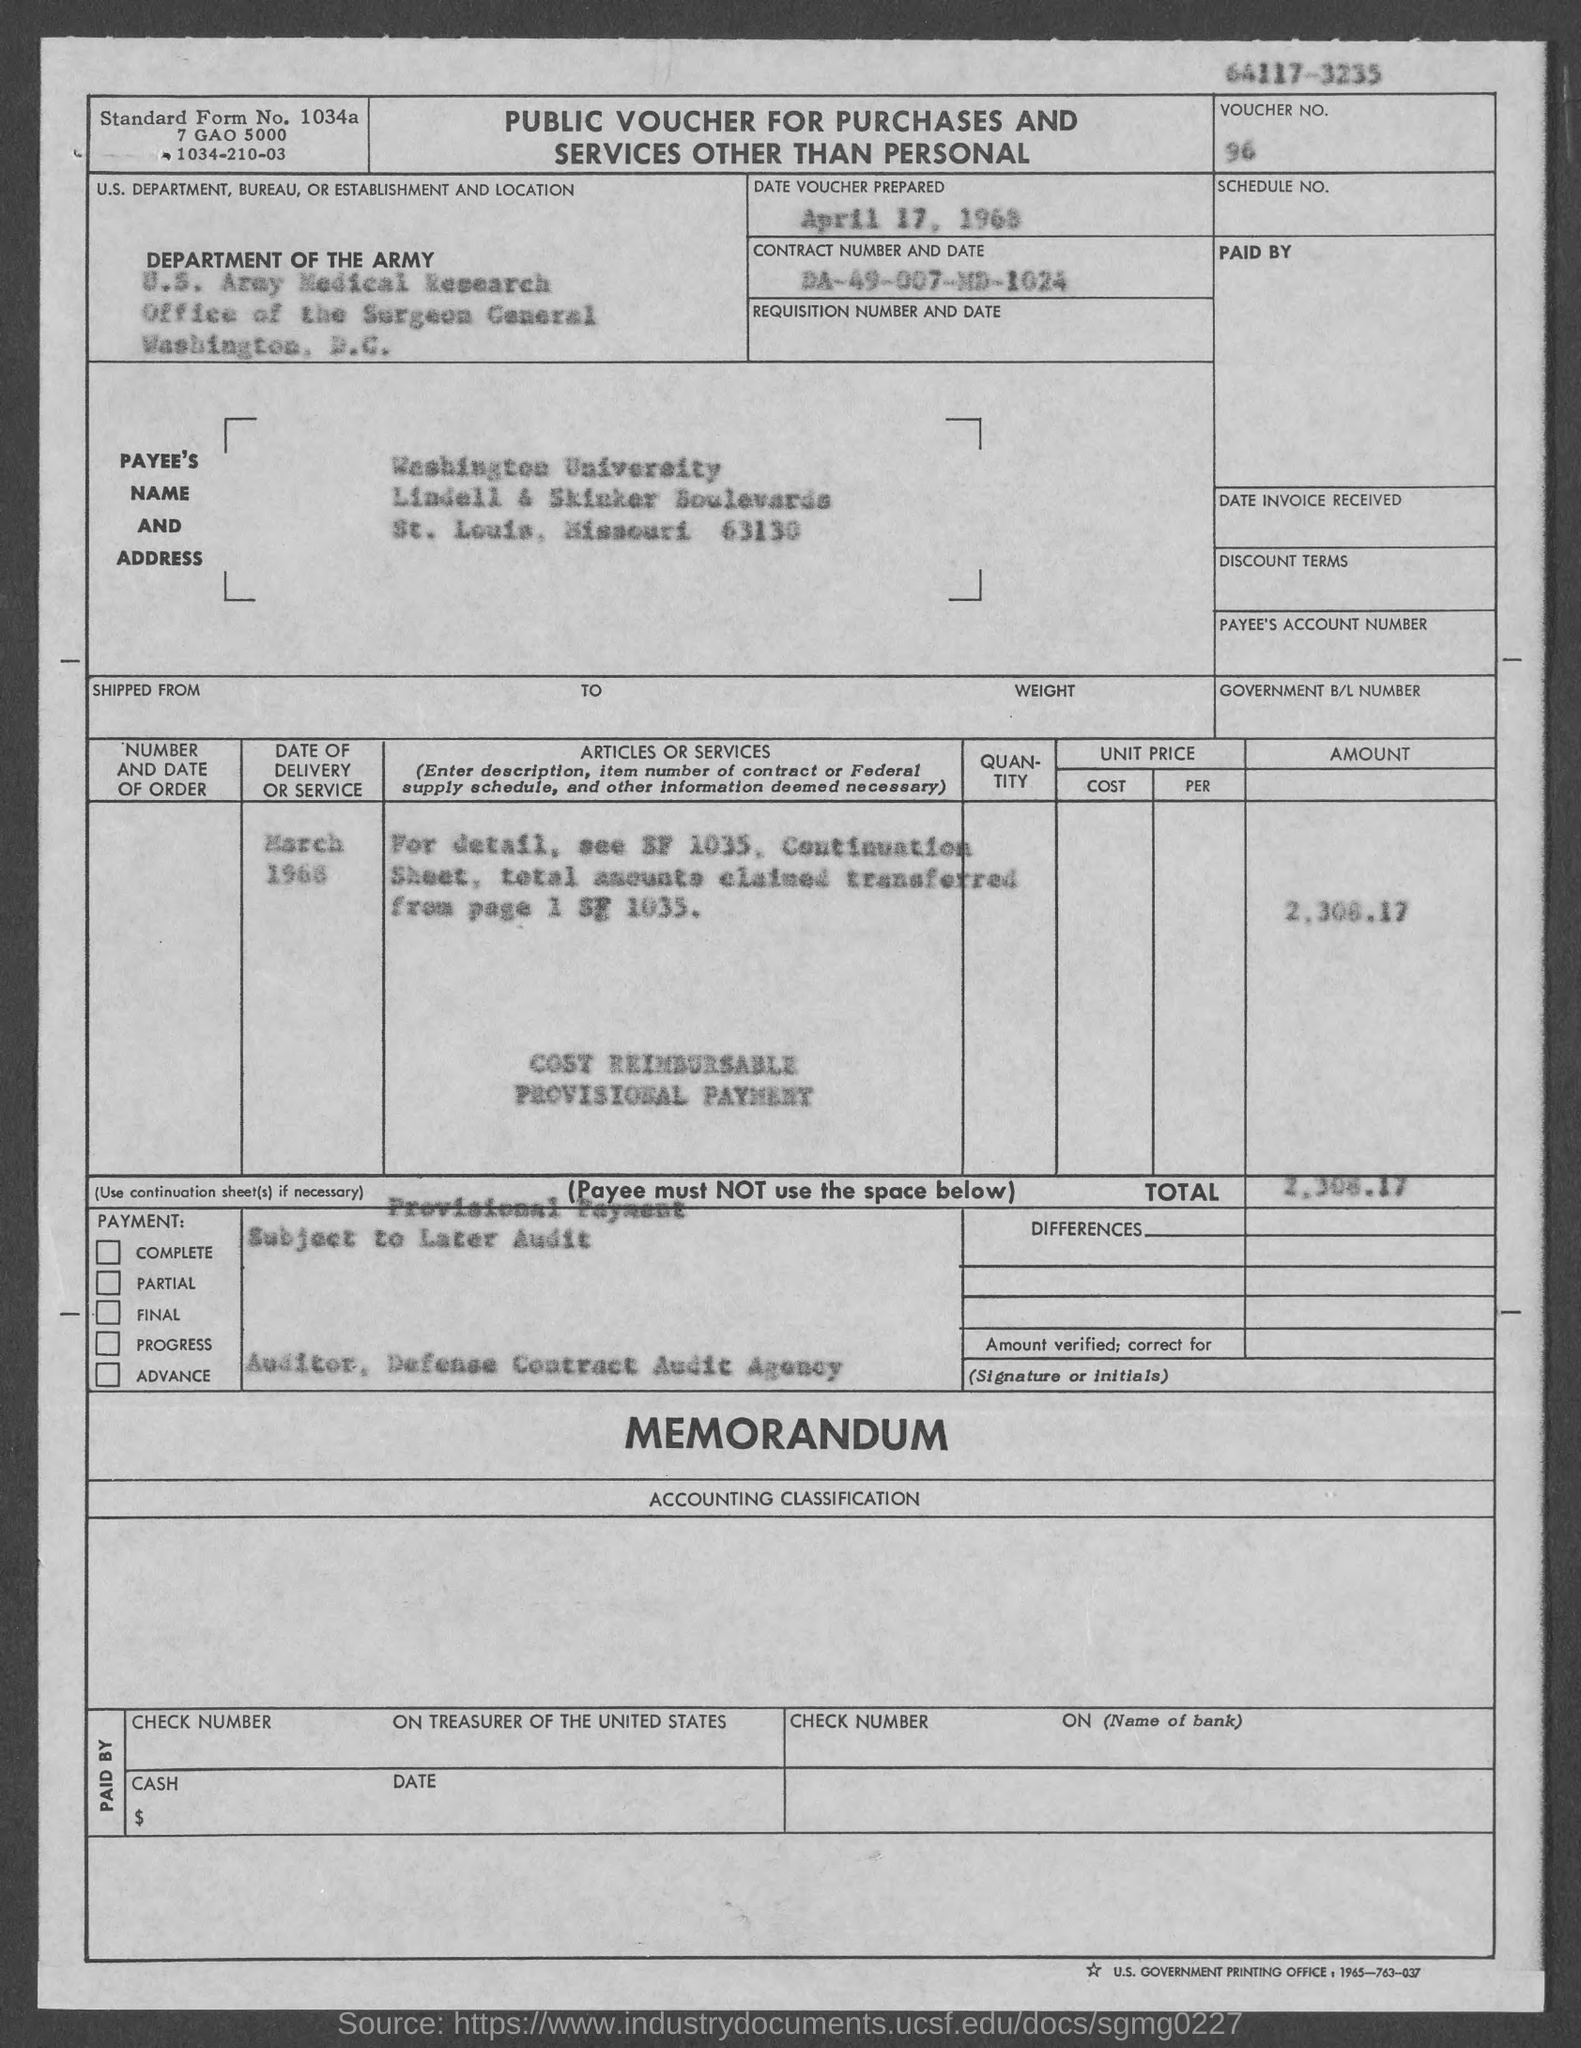What is the payee's zip code?
Keep it short and to the point. 63130. What is the voucher no.?
Provide a short and direct response. 96. When was the voucher prepared?
Provide a succinct answer. April 17, 1968. What is the main heading on the table?
Give a very brief answer. Public Voucher for Purchases and services other than personal. 